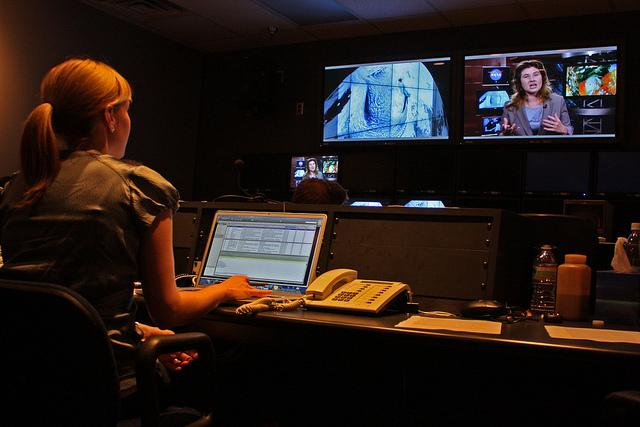What is the woman doing?

Choices:
A) working
B) checking emails
C) taking calls
D) watching tv working 